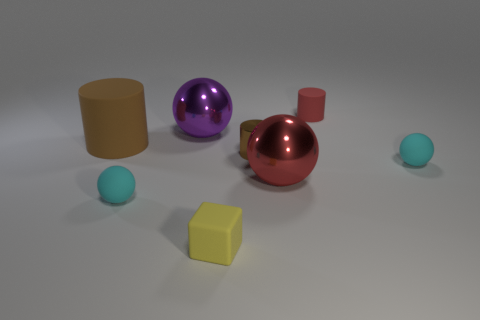There is another cylinder that is the same color as the large matte cylinder; what is it made of?
Offer a terse response. Metal. There is a rubber ball left of the purple ball; is its color the same as the rubber sphere to the right of the yellow matte thing?
Your answer should be very brief. Yes. What is the shape of the tiny matte object that is behind the tiny cyan rubber ball that is on the right side of the small metal cylinder that is on the right side of the yellow object?
Provide a short and direct response. Cylinder. There is a metallic thing that is on the right side of the yellow object and behind the big red object; what is its shape?
Keep it short and to the point. Cylinder. There is a cyan object in front of the cyan rubber thing that is on the right side of the large red sphere; how many small brown metal objects are left of it?
Give a very brief answer. 0. There is a red object that is the same shape as the big purple object; what size is it?
Provide a short and direct response. Large. Is the material of the tiny sphere that is right of the tiny metal cylinder the same as the big brown thing?
Your answer should be very brief. Yes. What is the color of the shiny thing that is the same shape as the tiny red rubber thing?
Give a very brief answer. Brown. How many other objects are there of the same color as the block?
Provide a short and direct response. 0. Is the shape of the small cyan object right of the purple object the same as the big purple metallic object that is to the left of the yellow object?
Offer a terse response. Yes. 